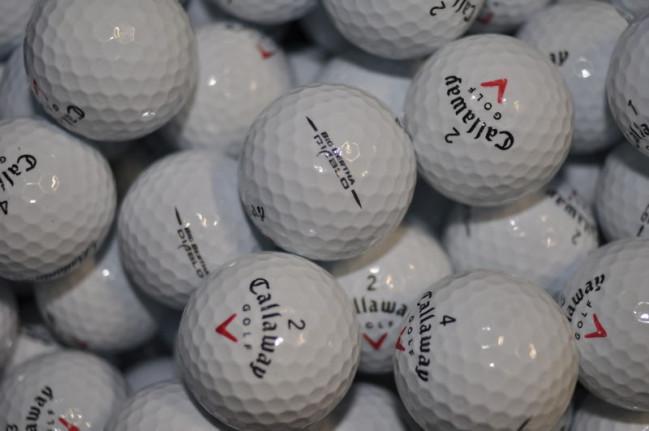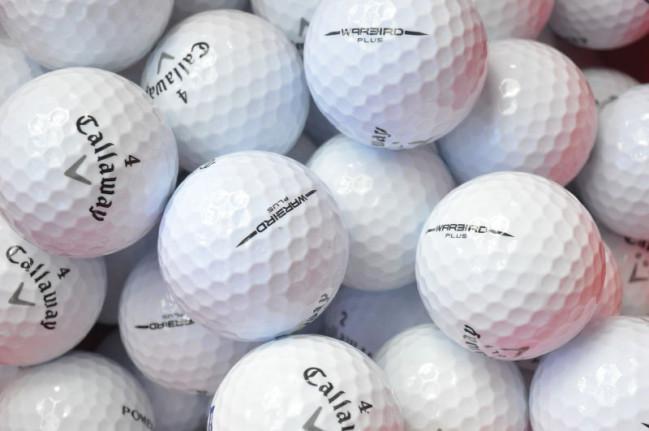The first image is the image on the left, the second image is the image on the right. Evaluate the accuracy of this statement regarding the images: "The golfballs in the image on the right are not in shadow.". Is it true? Answer yes or no. Yes. The first image is the image on the left, the second image is the image on the right. Considering the images on both sides, is "Golf balls in the left image look noticeably darker and grayer than those in the right image." valid? Answer yes or no. Yes. 